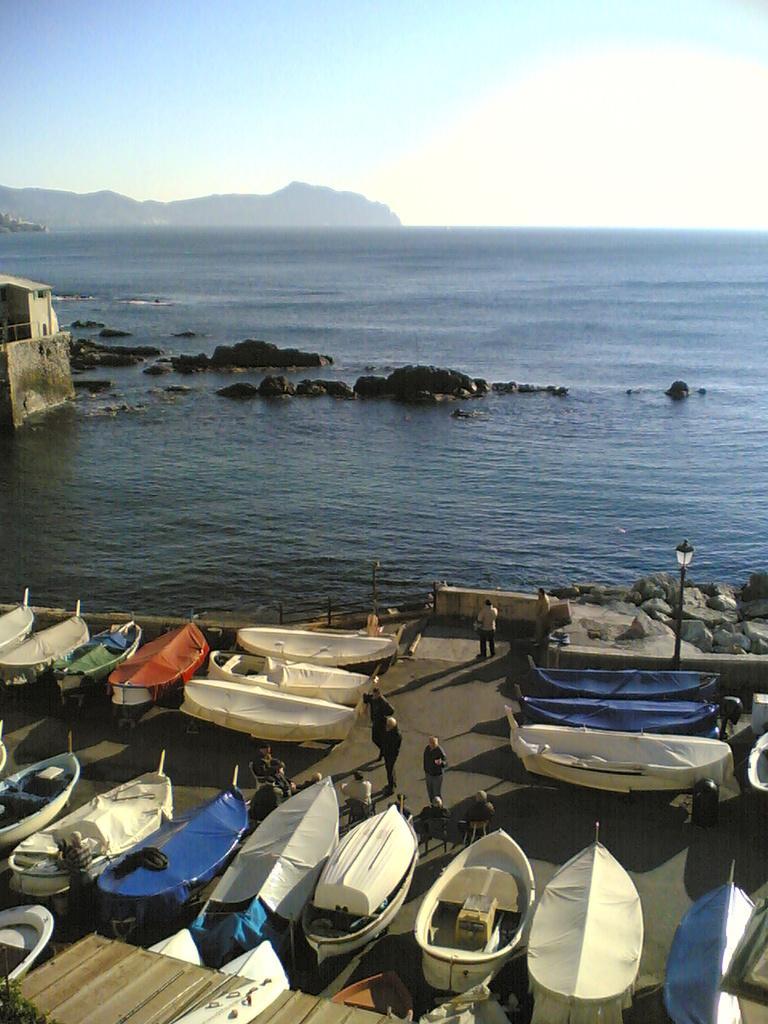Please provide a concise description of this image. At the bottom of the image we can see some boats and few people are standing and there is a pole. Behind the boats there is fencing and stones. In the middle of the image there is water. Behind the water there are some hills and clouds and sky. 